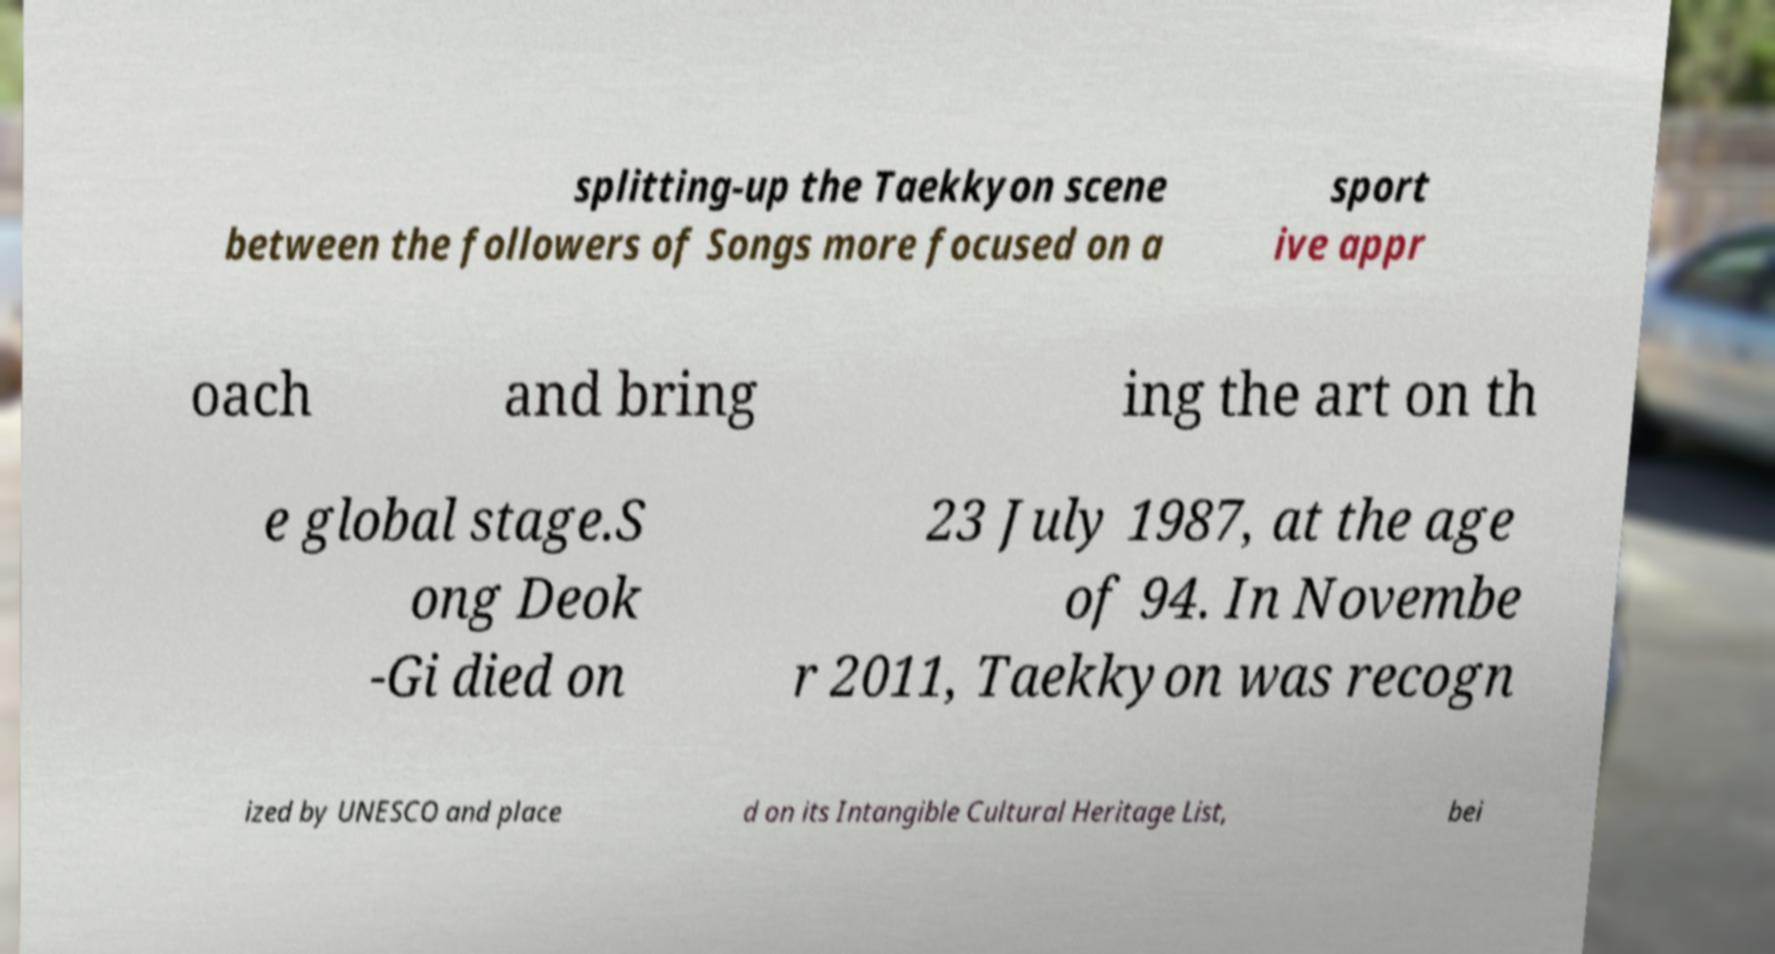I need the written content from this picture converted into text. Can you do that? splitting-up the Taekkyon scene between the followers of Songs more focused on a sport ive appr oach and bring ing the art on th e global stage.S ong Deok -Gi died on 23 July 1987, at the age of 94. In Novembe r 2011, Taekkyon was recogn ized by UNESCO and place d on its Intangible Cultural Heritage List, bei 